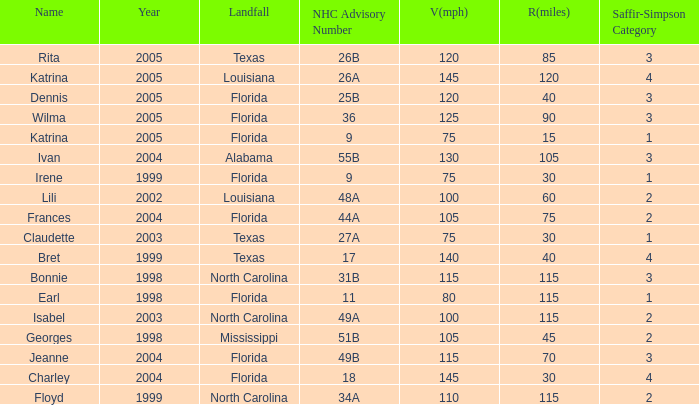What was the lowest V(mph) for a Saffir-Simpson of 4 in 2005? 145.0. 